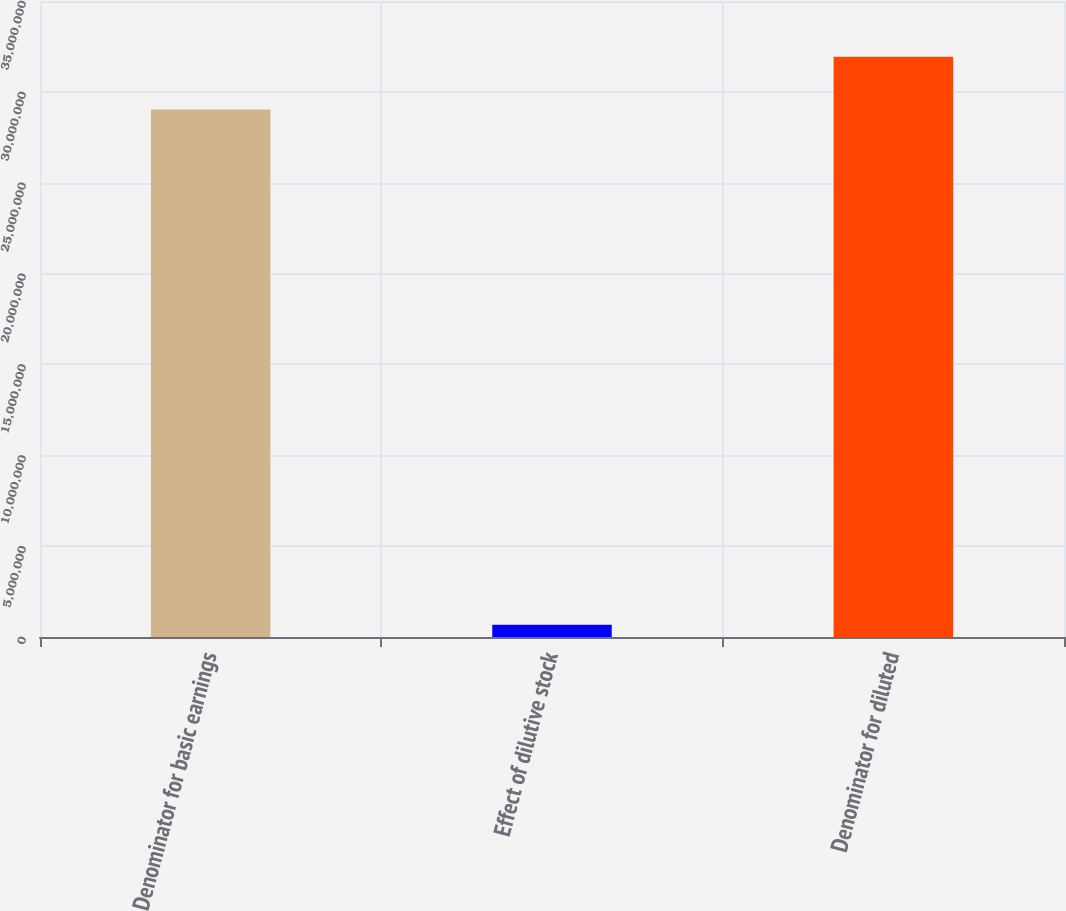<chart> <loc_0><loc_0><loc_500><loc_500><bar_chart><fcel>Denominator for basic earnings<fcel>Effect of dilutive stock<fcel>Denominator for diluted<nl><fcel>2.90313e+07<fcel>679564<fcel>3.19344e+07<nl></chart> 